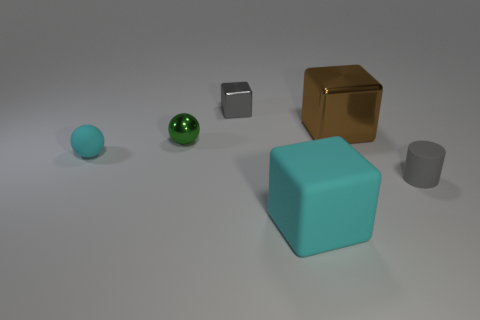Add 4 big spheres. How many objects exist? 10 Subtract all cylinders. How many objects are left? 5 Add 5 tiny things. How many tiny things are left? 9 Add 4 metal things. How many metal things exist? 7 Subtract 0 red cubes. How many objects are left? 6 Subtract all big brown things. Subtract all green shiny cylinders. How many objects are left? 5 